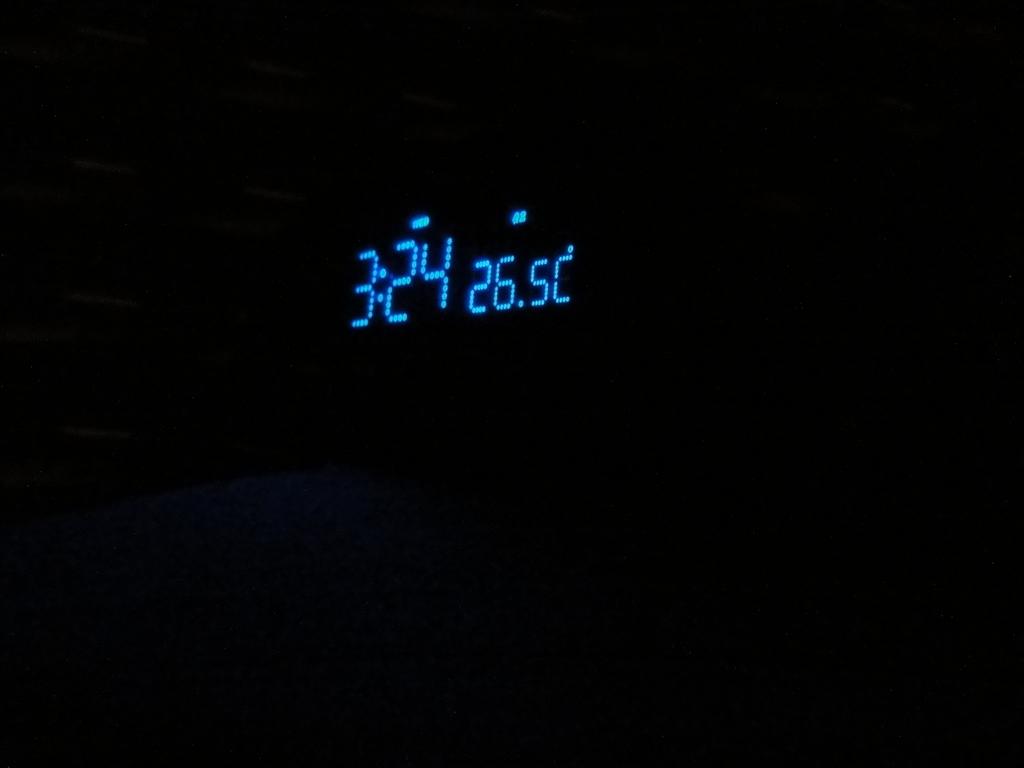What time is on the digital clock?
Make the answer very short. 3:24. 